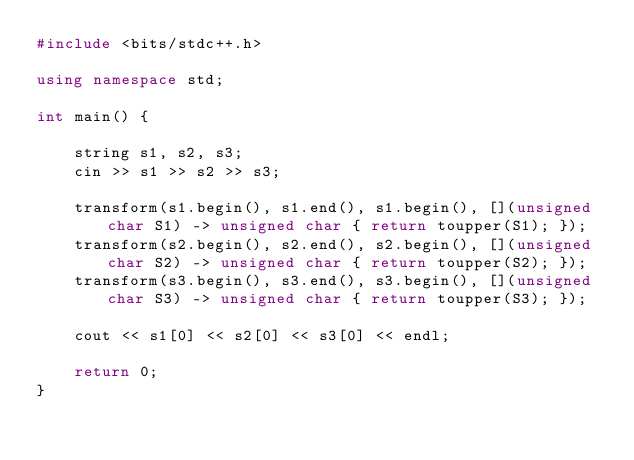<code> <loc_0><loc_0><loc_500><loc_500><_C++_>#include <bits/stdc++.h>

using namespace std;

int main() {

	string s1, s2, s3;
	cin >> s1 >> s2 >> s3;

	transform(s1.begin(), s1.end(), s1.begin(), [](unsigned char S1) -> unsigned char { return toupper(S1); });
	transform(s2.begin(), s2.end(), s2.begin(), [](unsigned char S2) -> unsigned char { return toupper(S2); });
	transform(s3.begin(), s3.end(), s3.begin(), [](unsigned char S3) -> unsigned char { return toupper(S3); });

	cout << s1[0] << s2[0] << s3[0] << endl;

	return 0;
}</code> 